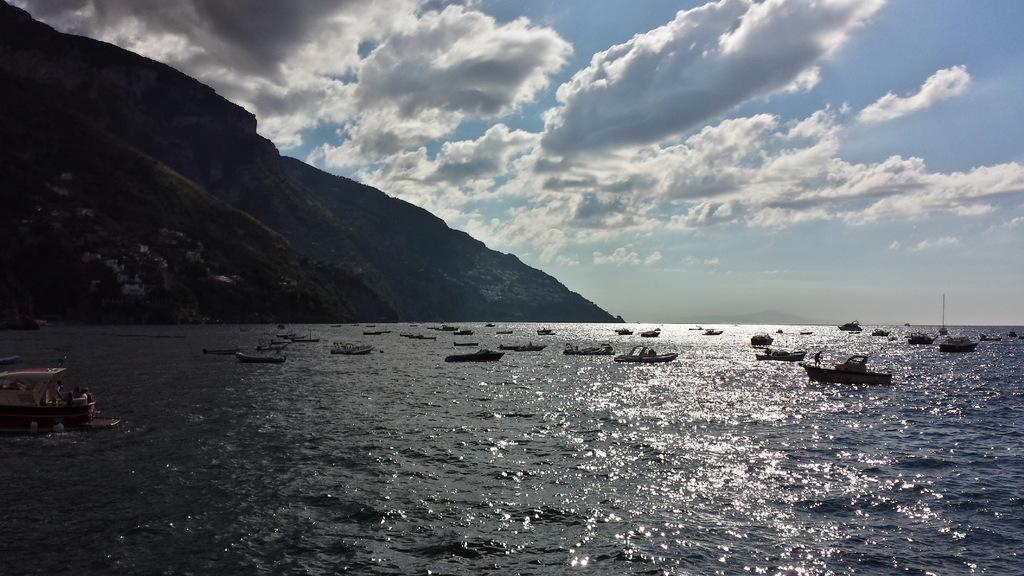What is in the front of the image? There is water in the front of the image. What is happening on the water? There are boats sailing on the water. What can be seen in the background of the image? There are mountains in the background of the image. How would you describe the sky in the image? The sky is cloudy. How many apples are floating on the water in the image? There are no apples present in the image; it features water with boats sailing on it. What type of ink is being used to draw the mountains in the image? There is no ink present in the image, as it is a photograph or digital representation of the scene. 